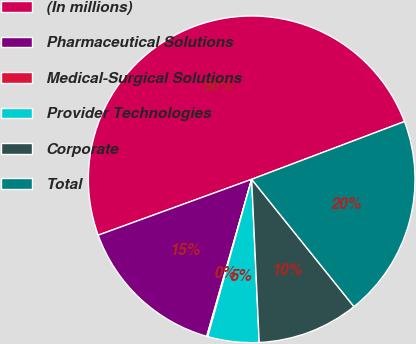<chart> <loc_0><loc_0><loc_500><loc_500><pie_chart><fcel>(In millions)<fcel>Pharmaceutical Solutions<fcel>Medical-Surgical Solutions<fcel>Provider Technologies<fcel>Corporate<fcel>Total<nl><fcel>49.8%<fcel>15.01%<fcel>0.1%<fcel>5.07%<fcel>10.04%<fcel>19.98%<nl></chart> 